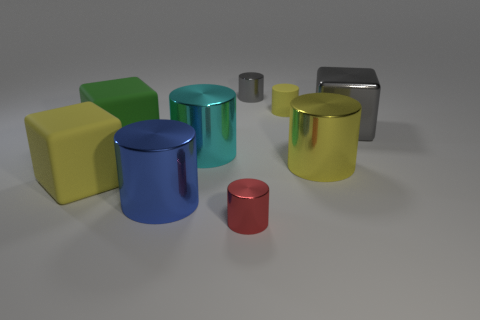There is a metallic cylinder that is right of the gray cylinder; is it the same color as the tiny metal thing that is behind the big gray shiny thing?
Provide a succinct answer. No. There is a shiny cylinder that is the same color as the metallic cube; what is its size?
Offer a terse response. Small. Is there a small gray shiny object?
Your response must be concise. Yes. The yellow object that is on the left side of the blue metallic thing that is left of the yellow cylinder behind the large gray cube is what shape?
Provide a short and direct response. Cube. There is a big green matte thing; what number of cylinders are behind it?
Ensure brevity in your answer.  2. Is the yellow thing left of the big blue object made of the same material as the cyan cylinder?
Your response must be concise. No. What number of other objects are the same shape as the small red object?
Make the answer very short. 5. How many large metal cubes are behind the small thing that is behind the matte thing that is to the right of the cyan metallic cylinder?
Provide a succinct answer. 0. There is a cube that is behind the large green thing; what color is it?
Give a very brief answer. Gray. There is a big rubber cube that is left of the green object; is its color the same as the metal cube?
Offer a terse response. No. 